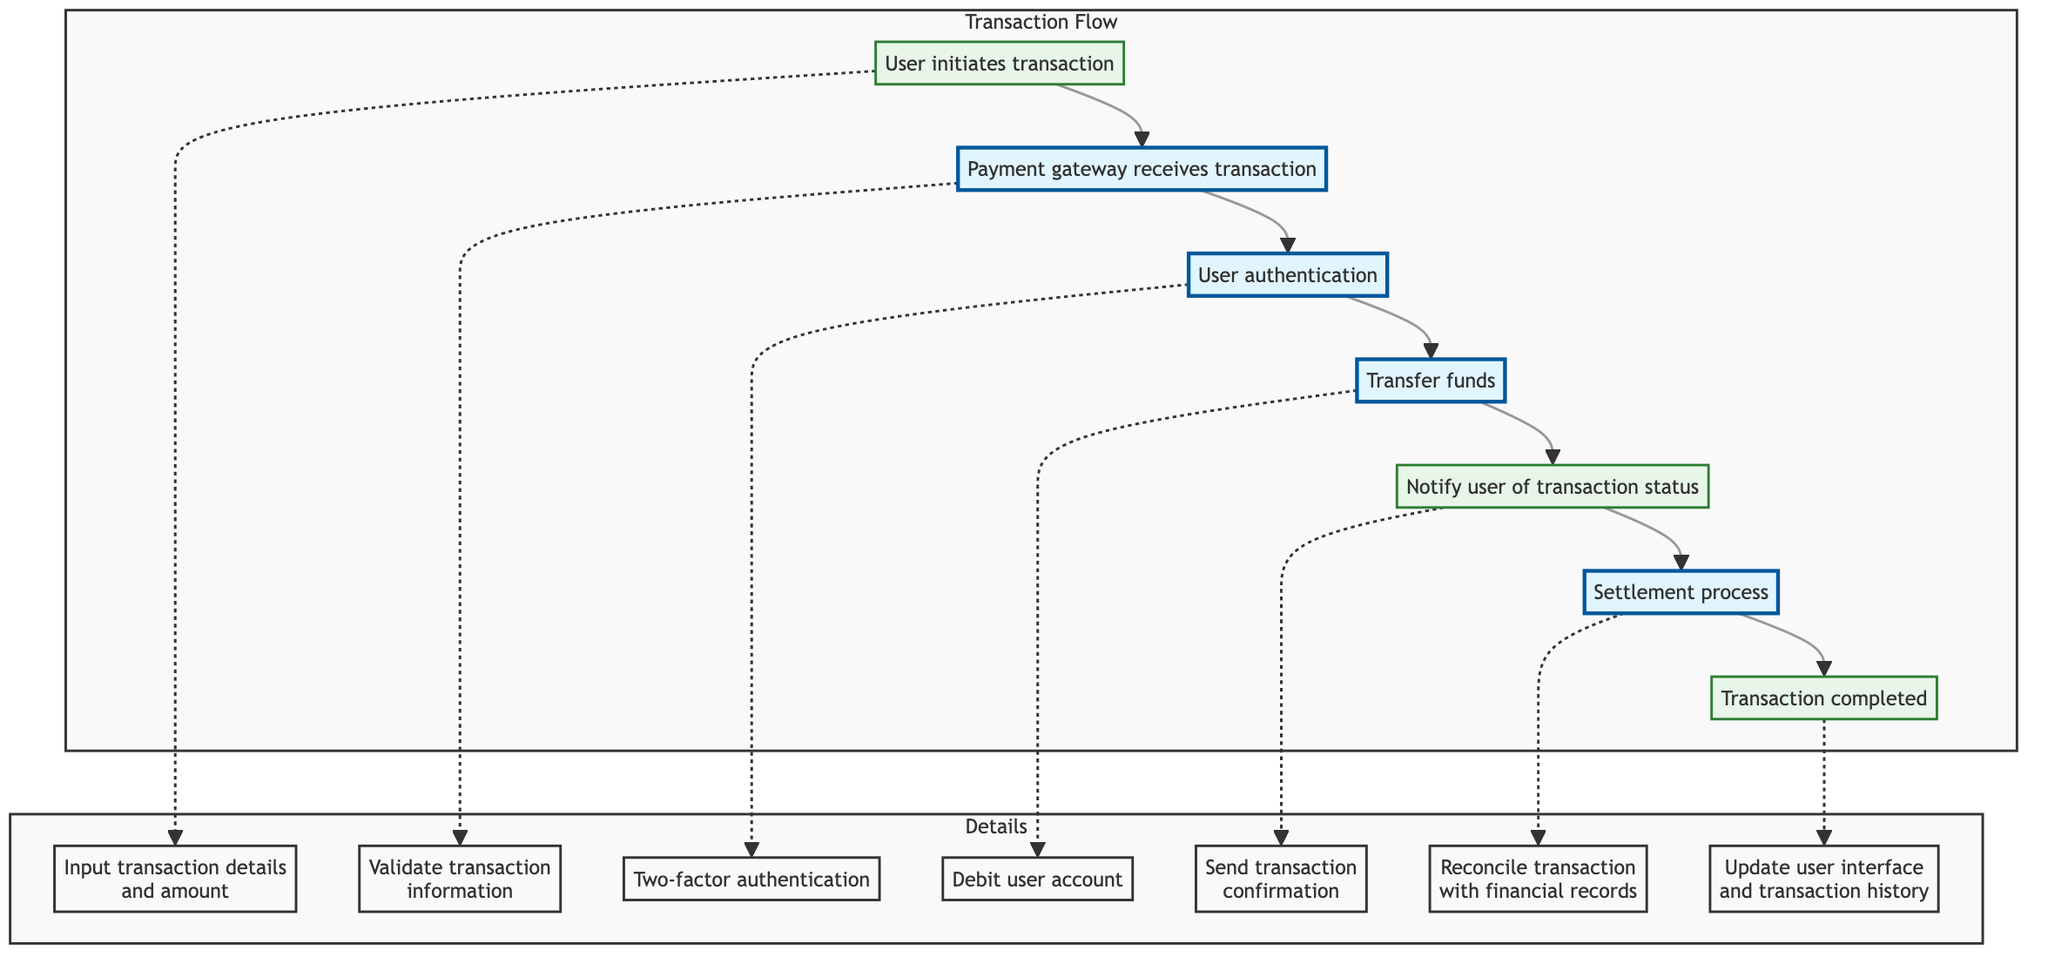What is the first step in the transaction flow? The diagram indicates that the first step is "User initiates transaction." This is the starting point and is clearly labeled at the top of the flow.
Answer: User initiates transaction Who receives the transaction after user initiation? After user initiation, the "Payment gateway receives transaction" is the next step outlined in the diagram, showing a clear flow from the user to the payment gateway.
Answer: Payment gateway receives transaction How many main steps are there in the transaction flow? By counting the steps from user initiation to transaction completion, there are a total of 7 main steps represented in the flowchart.
Answer: 7 What action is taken during user authentication? The diagram explicitly states that the action taken during this step is "Two-factor authentication," clearly specifying what occurs at this point in the flow.
Answer: Two-factor authentication Which system is used for reconciliation in the settlement process? The diagram specifies that the system used for reconciliation during the settlement process is "QuickBooks," providing a clear indication of the tools involved.
Answer: QuickBooks What action takes place after the funds are transferred? According to the diagram, immediately after the funds are transferred, the action that takes place is "Notify user of transaction status," which indicates the next step in the flow.
Answer: Notify user of transaction status What method is used for user authentication? The flowchart highlights that the method for user authentication is "SMS or authenticator app," indicating the security measures taken during this step.
Answer: SMS or authenticator app What happens at the transaction completion step? At the transaction completion step, the action is to "Update user interface and transaction history," meaning this is the final action before concluding the flow.
Answer: Update user interface and transaction history How does the payment process begin? The payment process begins when the "Payment gateway receives transaction," which is the second step and marks the start of payment processing in the flow.
Answer: Payment gateway receives transaction 